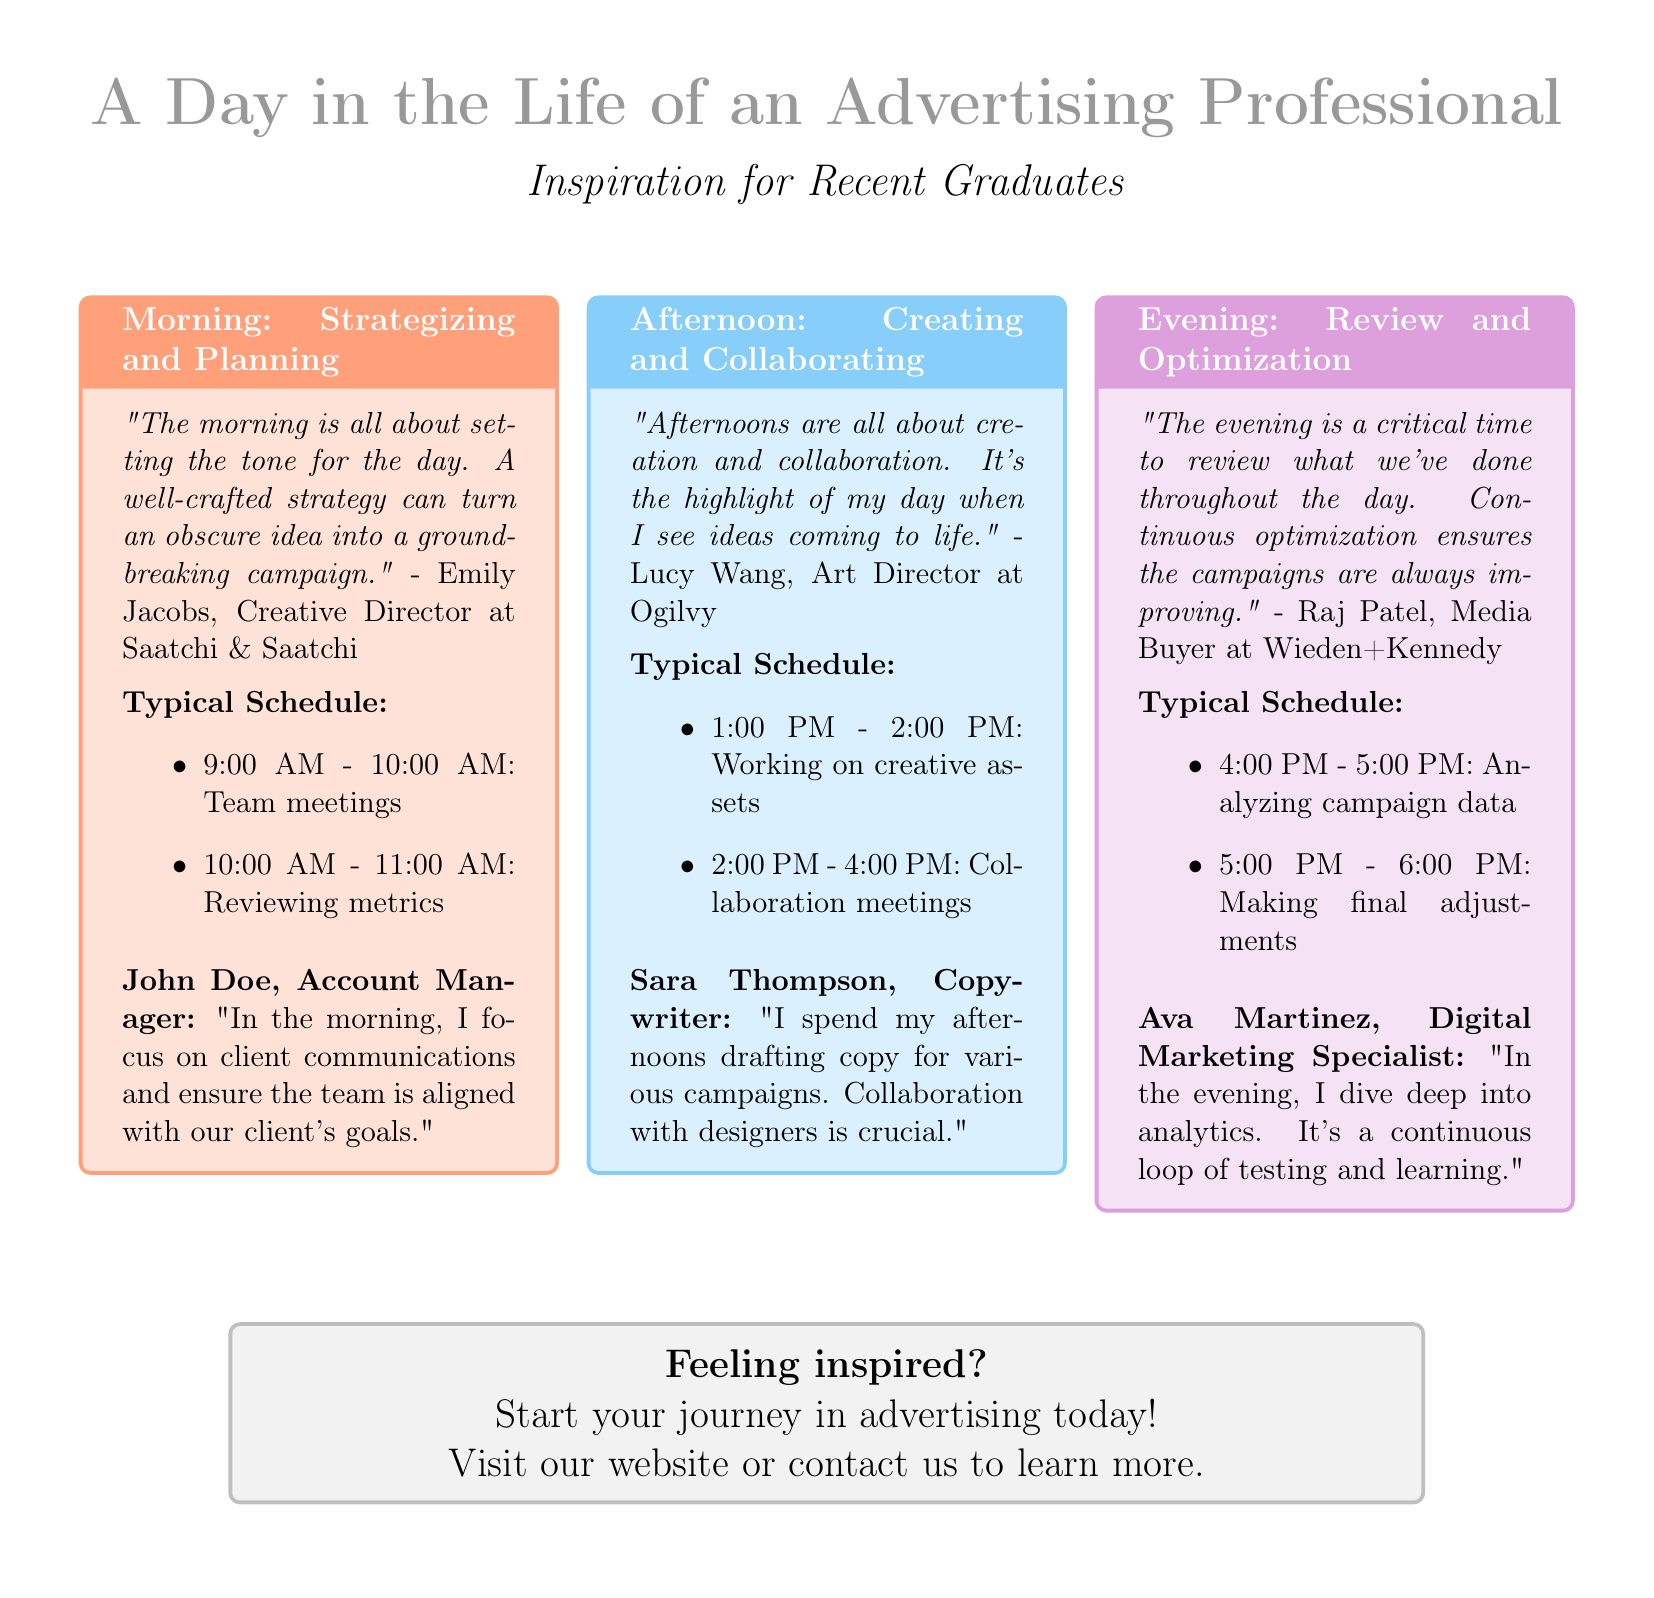What is the title of the flyer? The title of the flyer is prominently displayed at the top of the document.
Answer: A Day in the Life of an Advertising Professional Who is the Creative Director at Saatchi & Saatchi? The flyer includes a quote from a Creative Director, identifying them by name and company.
Answer: Emily Jacobs What color is used to represent the afternoon section? The document specifies a color for each daily section, which can be found in the titles.
Answer: Afternoon color is light blue How many items are listed in the morning typical schedule? The typical schedule for the morning lists specific activities, and we can count them.
Answer: 2 items What is involved in Ava Martinez's evening schedule? The evening schedule shows specific activities, and the answer extracts them directly.
Answer: Analyzing campaign data and making final adjustments Which advertising role focuses on drafting copy? The document mentions specific roles associated with tasks, allowing us to identify a role by a key function.
Answer: Copywriter What is the primary activity of the morning for an Account Manager? The flyer specifies the focus of the Account Manager's morning, allowing us to extract that detail.
Answer: Client communications How can graduates start their journey in advertising? The flyer concludes with a call to action, prompting specific next steps for graduates.
Answer: Visit our website or contact us 